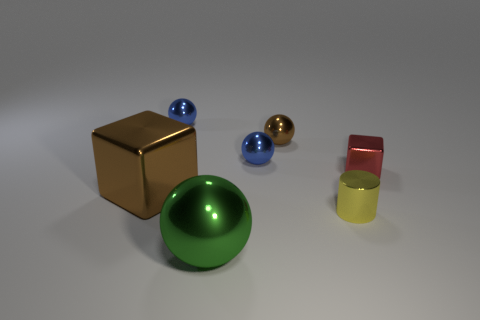Subtract 1 balls. How many balls are left? 3 Add 2 small brown balls. How many objects exist? 9 Subtract all cylinders. How many objects are left? 6 Add 7 large green metallic things. How many large green metallic things are left? 8 Add 1 red cubes. How many red cubes exist? 2 Subtract 0 brown cylinders. How many objects are left? 7 Subtract all cyan metallic balls. Subtract all tiny metallic balls. How many objects are left? 4 